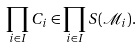<formula> <loc_0><loc_0><loc_500><loc_500>\prod _ { i \in I } C _ { i } \in \prod _ { i \in I } S ( \mathcal { M } _ { i } ) .</formula> 